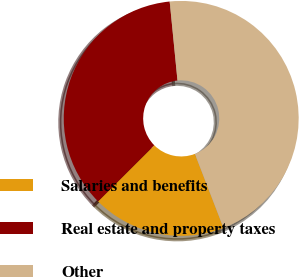Convert chart. <chart><loc_0><loc_0><loc_500><loc_500><pie_chart><fcel>Salaries and benefits<fcel>Real estate and property taxes<fcel>Other<nl><fcel>18.38%<fcel>35.92%<fcel>45.7%<nl></chart> 